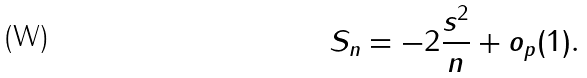<formula> <loc_0><loc_0><loc_500><loc_500>S _ { n } = - 2 \frac { s ^ { 2 } } { n } + o _ { p } ( 1 ) .</formula> 